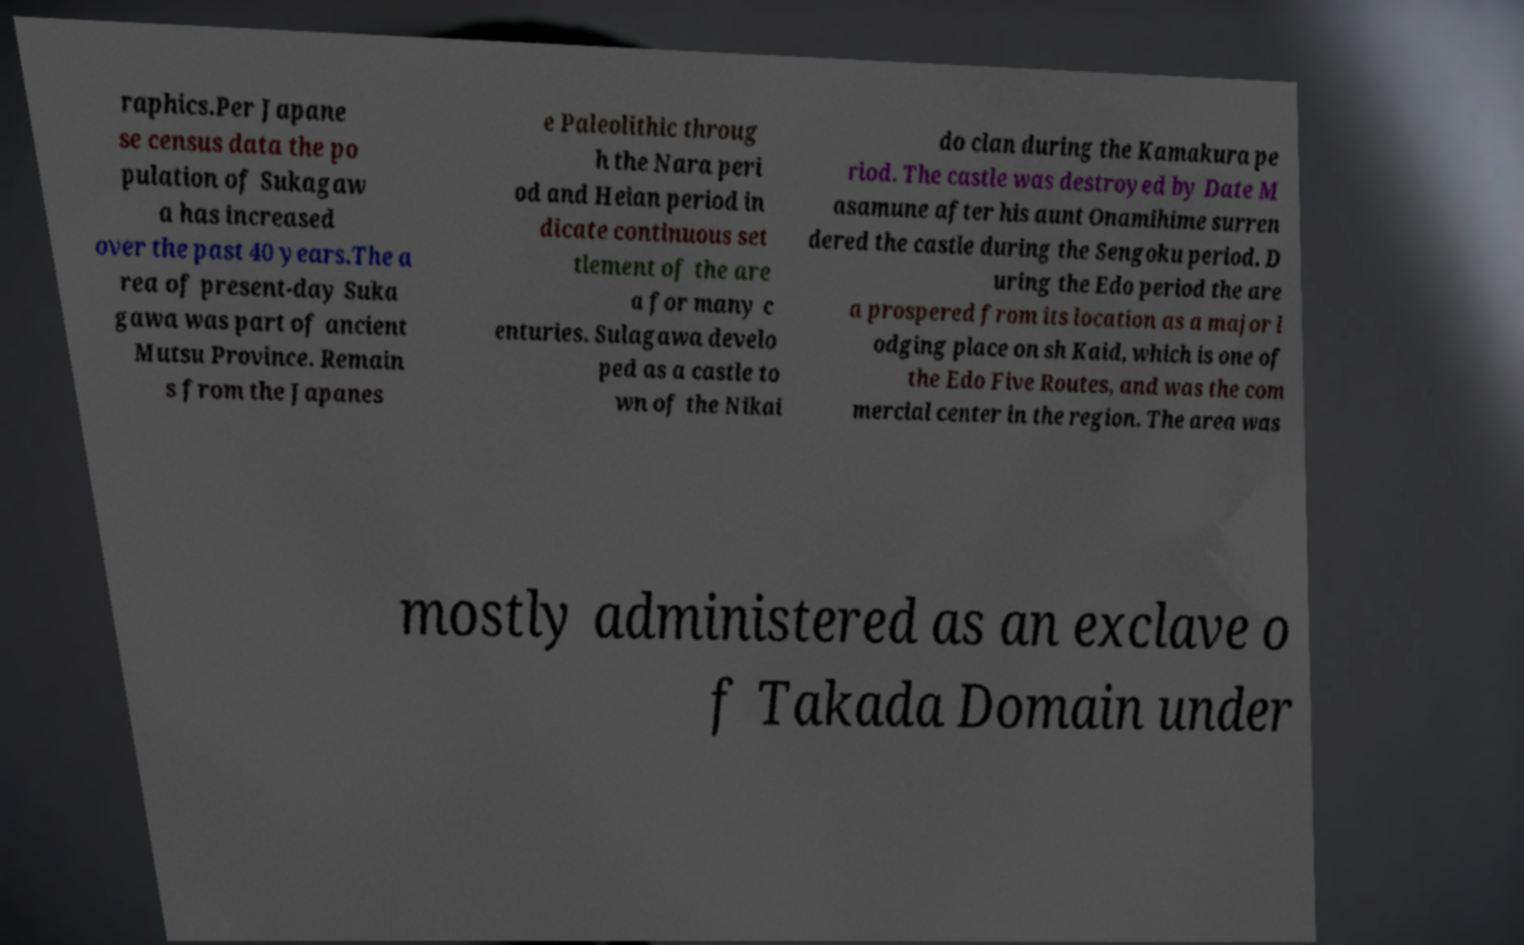Could you assist in decoding the text presented in this image and type it out clearly? raphics.Per Japane se census data the po pulation of Sukagaw a has increased over the past 40 years.The a rea of present-day Suka gawa was part of ancient Mutsu Province. Remain s from the Japanes e Paleolithic throug h the Nara peri od and Heian period in dicate continuous set tlement of the are a for many c enturies. Sulagawa develo ped as a castle to wn of the Nikai do clan during the Kamakura pe riod. The castle was destroyed by Date M asamune after his aunt Onamihime surren dered the castle during the Sengoku period. D uring the Edo period the are a prospered from its location as a major l odging place on sh Kaid, which is one of the Edo Five Routes, and was the com mercial center in the region. The area was mostly administered as an exclave o f Takada Domain under 